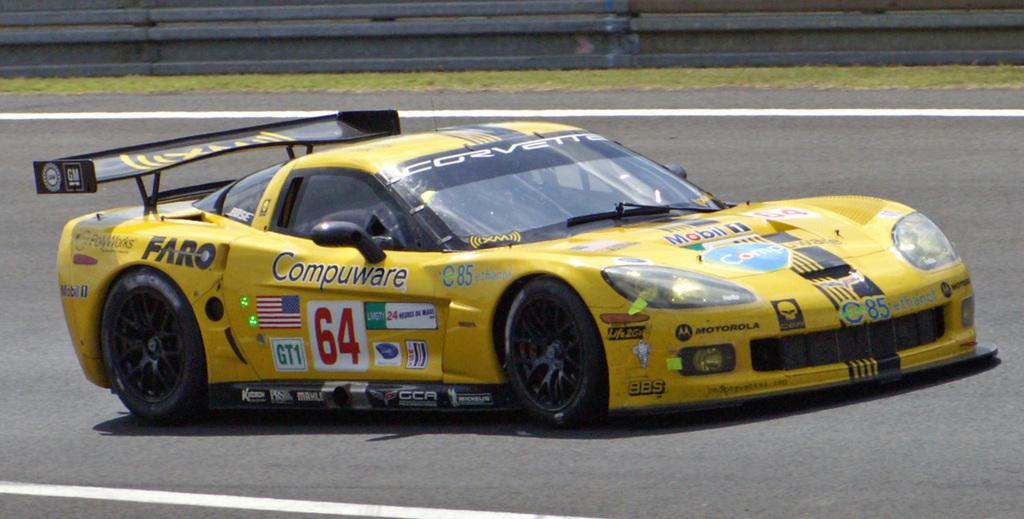What is the main subject of the image? There is a vehicle in the image. Where is the vehicle located? The vehicle is on the road. What type of house is visible in the image? There is no house present in the image; it only features a vehicle on the road. What color is the quartz in the image? There is no quartz present in the image. 